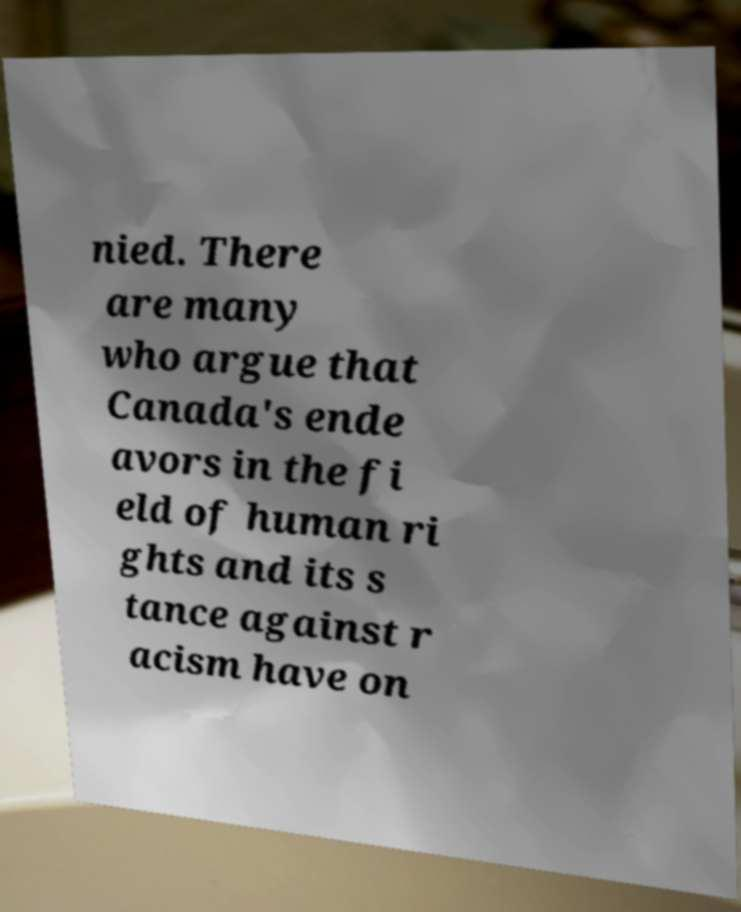Can you read and provide the text displayed in the image?This photo seems to have some interesting text. Can you extract and type it out for me? nied. There are many who argue that Canada's ende avors in the fi eld of human ri ghts and its s tance against r acism have on 